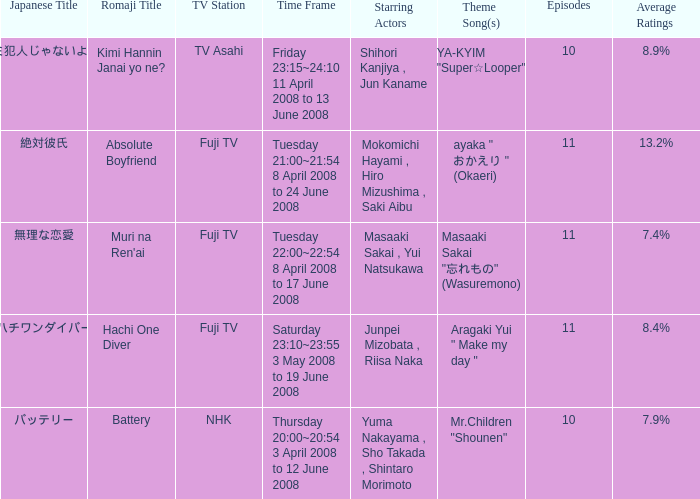What is the average rating for tv asahi? 8.9%. 